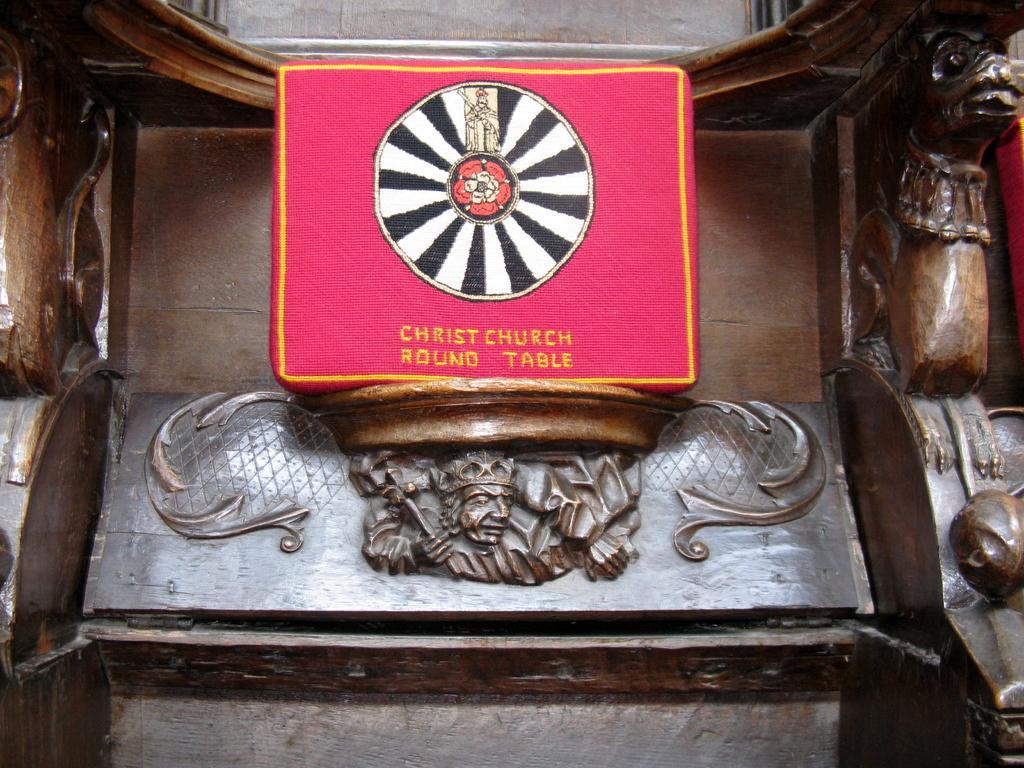In one or two sentences, can you explain what this image depicts? In the image there are some carvings on a wooden object. 